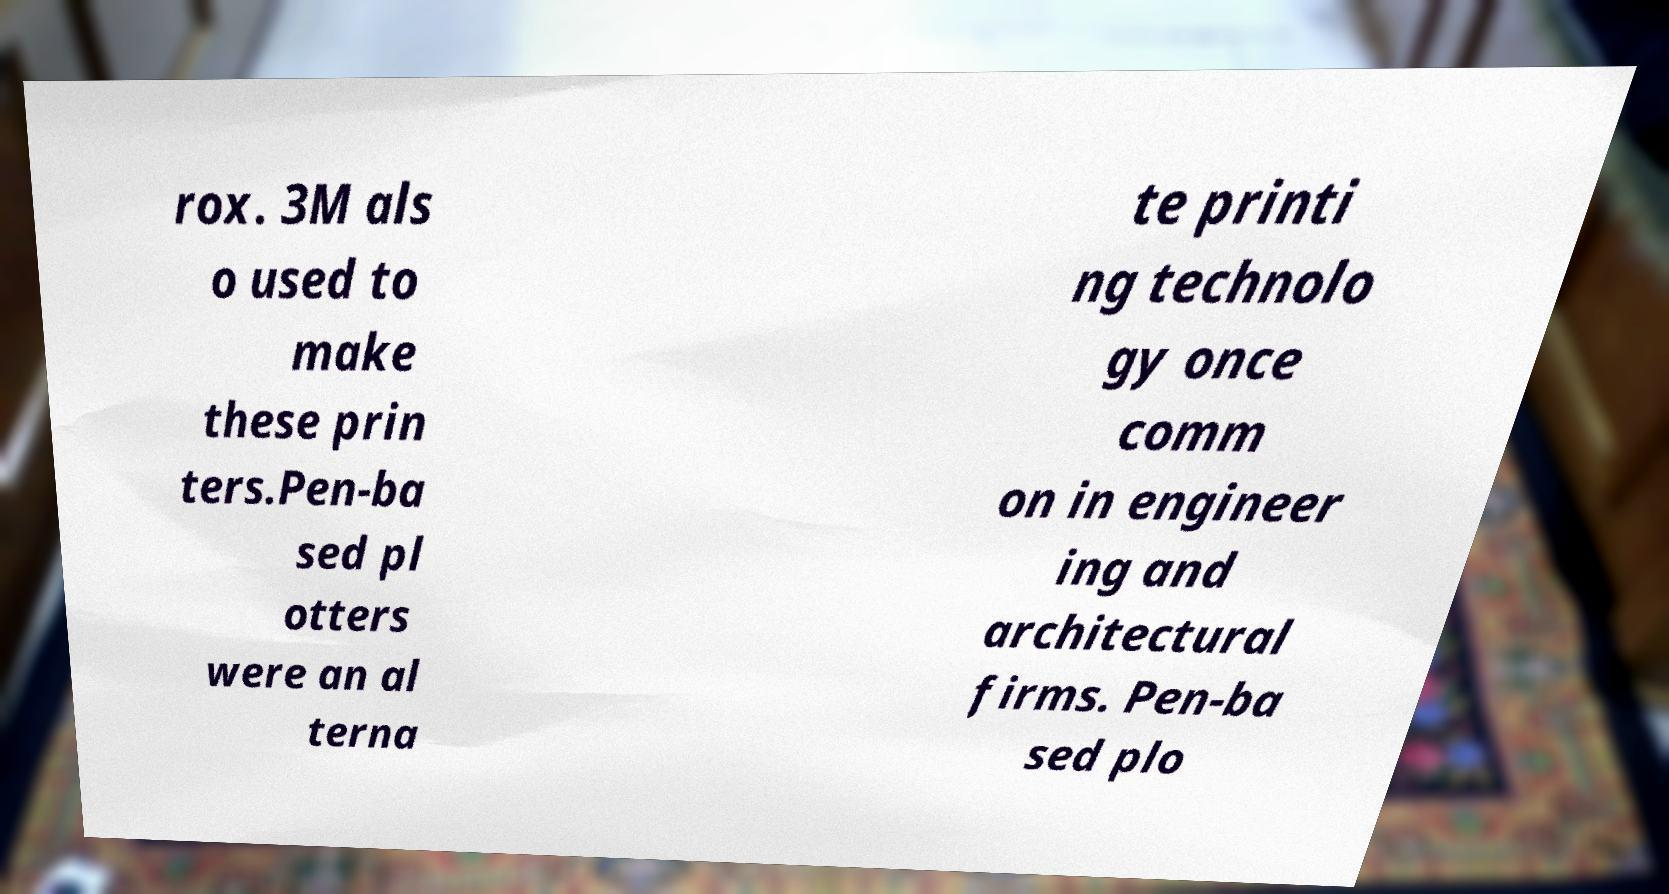There's text embedded in this image that I need extracted. Can you transcribe it verbatim? rox. 3M als o used to make these prin ters.Pen-ba sed pl otters were an al terna te printi ng technolo gy once comm on in engineer ing and architectural firms. Pen-ba sed plo 